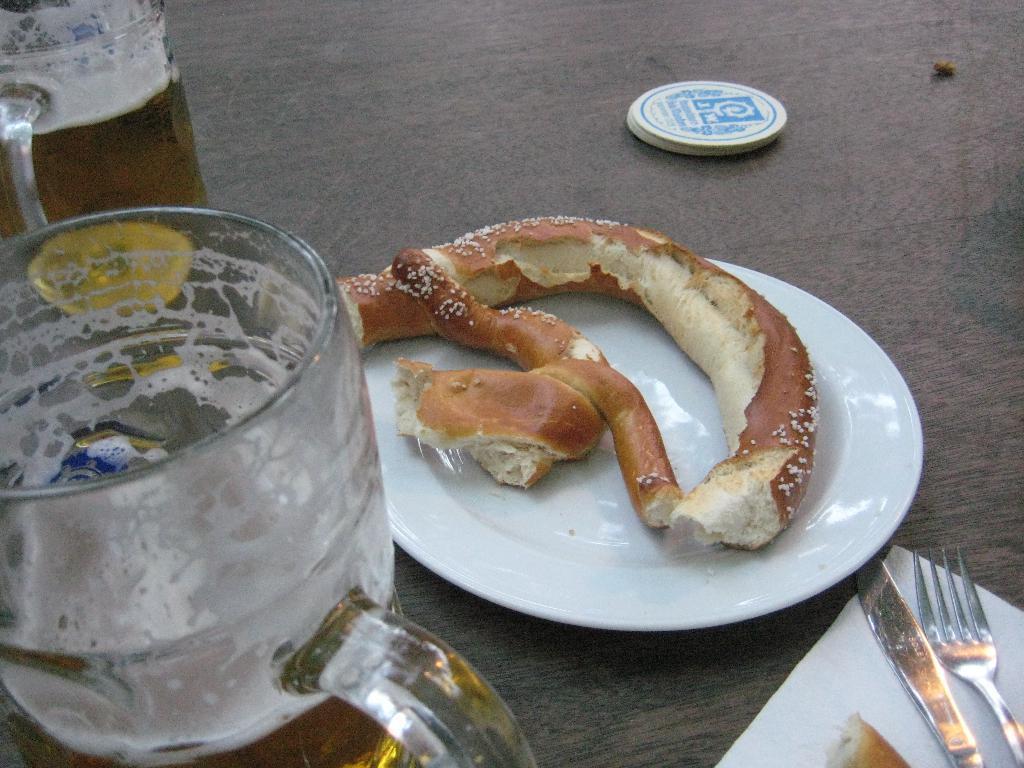Can you describe this image briefly? In this image we can see a plate with the food item and there are two glasses and we can see some other objects on the table. 